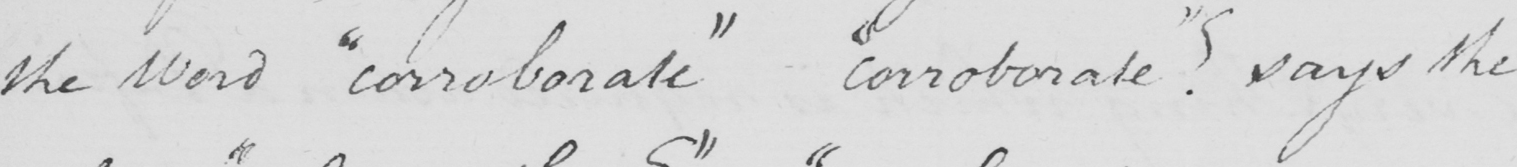What is written in this line of handwriting? the Word  " corroborate "  -  " corroborate "  ?  says the 